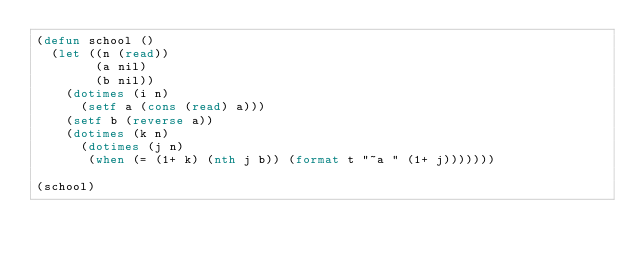<code> <loc_0><loc_0><loc_500><loc_500><_Lisp_>(defun school ()
  (let ((n (read))
        (a nil)
        (b nil))
    (dotimes (i n)
      (setf a (cons (read) a)))
    (setf b (reverse a))
    (dotimes (k n) 
      (dotimes (j n)
       (when (= (1+ k) (nth j b)) (format t "~a " (1+ j)))))))

(school)</code> 